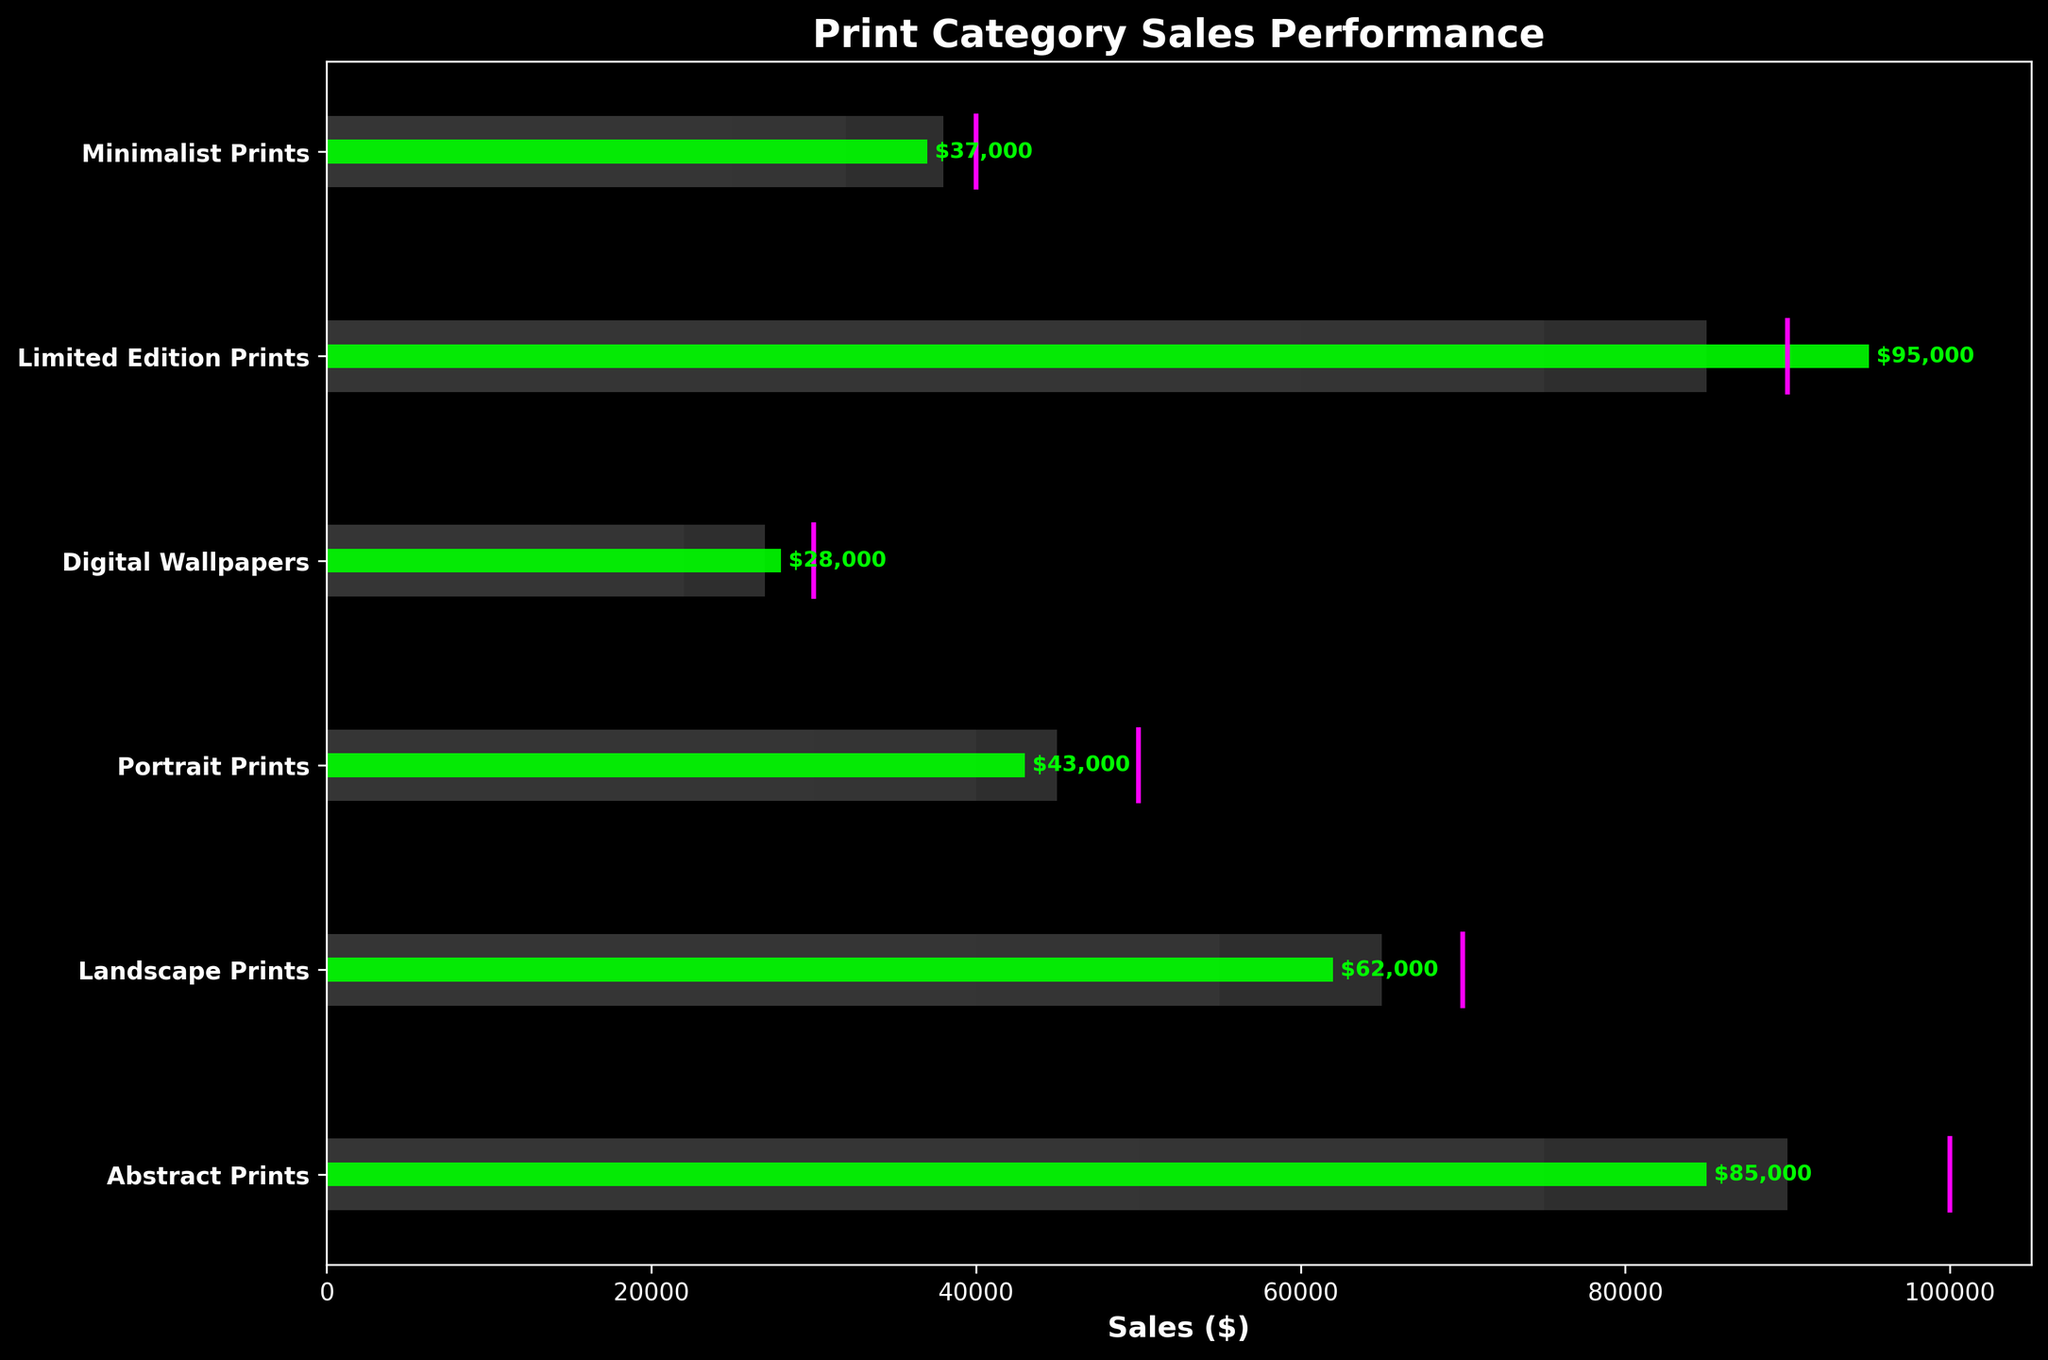What is the title of the chart? The title of the chart is located at the top and reads "Print Category Sales Performance."
Answer: Print Category Sales Performance How many print categories are shown in the chart? The chart displays a horizontal bar for each print category. Counting them gives a total of 6 categories.
Answer: 6 What is the sales target for Abstract Prints? The sales target for Abstract Prints is shown by a vertical line which intersects at $100,000.
Answer: $100,000 Which print category has achieved the highest actual sales? By looking at the green bars representing actual sales, the highest value corresponds to the Limited Edition Prints category.
Answer: Limited Edition Prints What is the actual sales amount for Minimalist Prints? The actual sales amount is found on the smaller green bar for Minimalist Prints, totaling $37,000.
Answer: $37,000 Which print category has an actual sales amount closest to its target? Comparing the green bars (actual sales) with the magenta vertical lines (targets), Limited Edition Prints has an actual amount ($95,000) closely matching its target ($90,000).
Answer: Limited Edition Prints How far below the target is the sales performance of Digital Wallpapers? The target for Digital Wallpapers is $30,000, and the actual sales are $28,000. The difference is $30,000 - $28,000 = $2,000.
Answer: $2,000 Which print categories did not meet their sales targets? Categories where the green bar (actual sales) does not reach the magenta line (target) are Abstract Prints, Landscape Prints, Portrait Prints, Digital Wallpapers, and Minimalist Prints.
Answer: Abstract Prints, Landscape Prints, Portrait Prints, Digital Wallpapers, Minimalist Prints What is the difference between the actual and target sales for Abstract Prints? The actual sales for Abstract Prints are $85,000 and the target is $100,000. The difference is $100,000 - $85,000 = $15,000.
Answer: $15,000 Which category has the largest difference between actual sales and the best-performing range (third range)? Comparing the actual to the highest range (third range) across categories, Abstract Prints' actual ($85,000) is closest to its third range ($90,000), missing by $5,000. Other categories either meet or exceed the third range.
Answer: Abstract Prints 